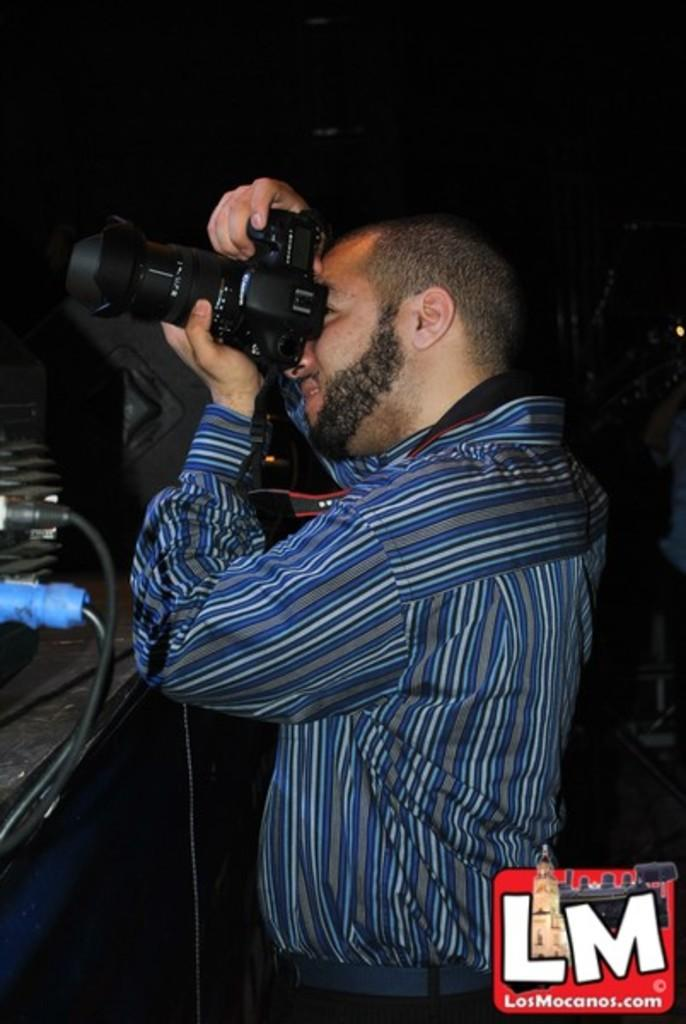Who is present in the image? There is a person in the image. What is the person holding in the image? The person is holding a camera. Can you describe the person's clothing in the image? The person is wearing a white and blue shirt. What color is the background of the image? The background of the image is black. What type of objects can be seen in addition to the person and the camera? There are black and blue color pins in the image. What type of cave can be seen in the background of the image? There is no cave present in the image; the background is black. 